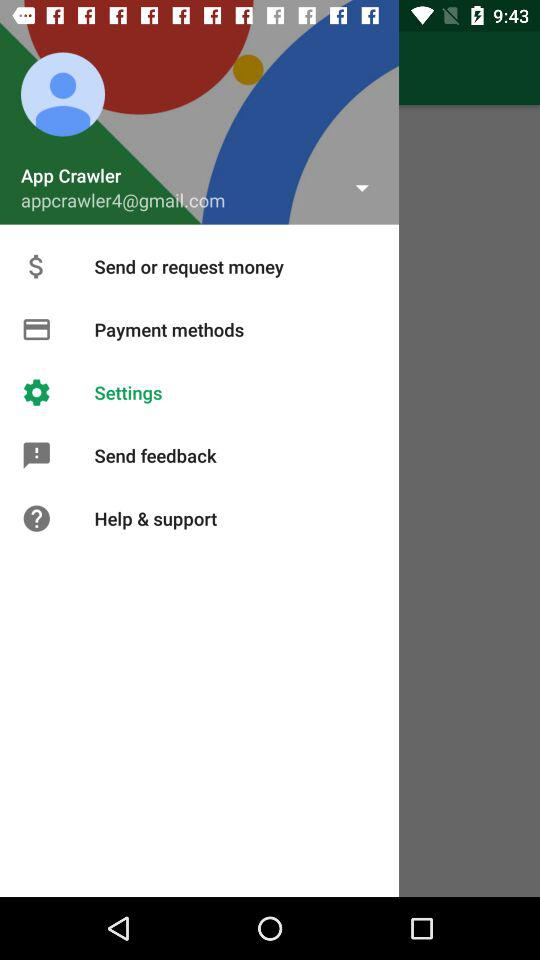What is the email address? The email address is appcrawler4@gmail.com. 